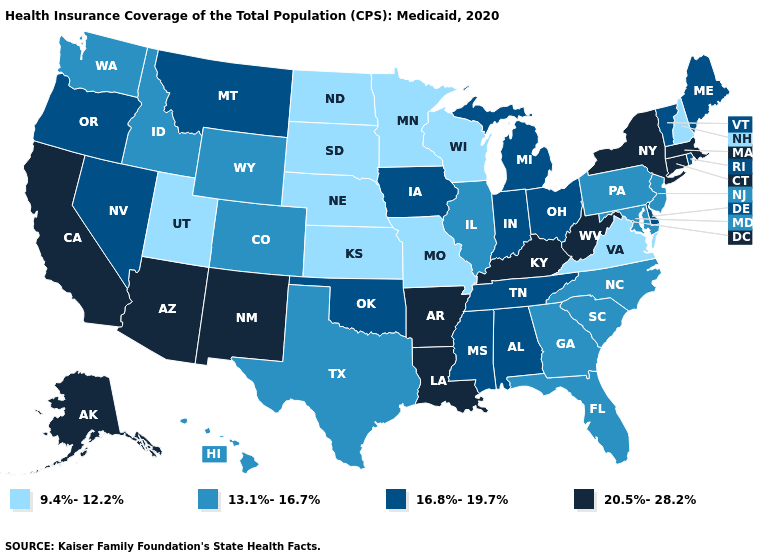What is the value of Oklahoma?
Keep it brief. 16.8%-19.7%. How many symbols are there in the legend?
Concise answer only. 4. What is the value of New Hampshire?
Short answer required. 9.4%-12.2%. Name the states that have a value in the range 13.1%-16.7%?
Be succinct. Colorado, Florida, Georgia, Hawaii, Idaho, Illinois, Maryland, New Jersey, North Carolina, Pennsylvania, South Carolina, Texas, Washington, Wyoming. Name the states that have a value in the range 20.5%-28.2%?
Give a very brief answer. Alaska, Arizona, Arkansas, California, Connecticut, Kentucky, Louisiana, Massachusetts, New Mexico, New York, West Virginia. What is the lowest value in the Northeast?
Give a very brief answer. 9.4%-12.2%. Name the states that have a value in the range 13.1%-16.7%?
Concise answer only. Colorado, Florida, Georgia, Hawaii, Idaho, Illinois, Maryland, New Jersey, North Carolina, Pennsylvania, South Carolina, Texas, Washington, Wyoming. Name the states that have a value in the range 16.8%-19.7%?
Be succinct. Alabama, Delaware, Indiana, Iowa, Maine, Michigan, Mississippi, Montana, Nevada, Ohio, Oklahoma, Oregon, Rhode Island, Tennessee, Vermont. Name the states that have a value in the range 20.5%-28.2%?
Quick response, please. Alaska, Arizona, Arkansas, California, Connecticut, Kentucky, Louisiana, Massachusetts, New Mexico, New York, West Virginia. Name the states that have a value in the range 20.5%-28.2%?
Keep it brief. Alaska, Arizona, Arkansas, California, Connecticut, Kentucky, Louisiana, Massachusetts, New Mexico, New York, West Virginia. Which states have the lowest value in the Northeast?
Short answer required. New Hampshire. What is the highest value in states that border Arkansas?
Concise answer only. 20.5%-28.2%. What is the lowest value in states that border Nevada?
Give a very brief answer. 9.4%-12.2%. Does Utah have the lowest value in the USA?
Quick response, please. Yes. How many symbols are there in the legend?
Concise answer only. 4. 